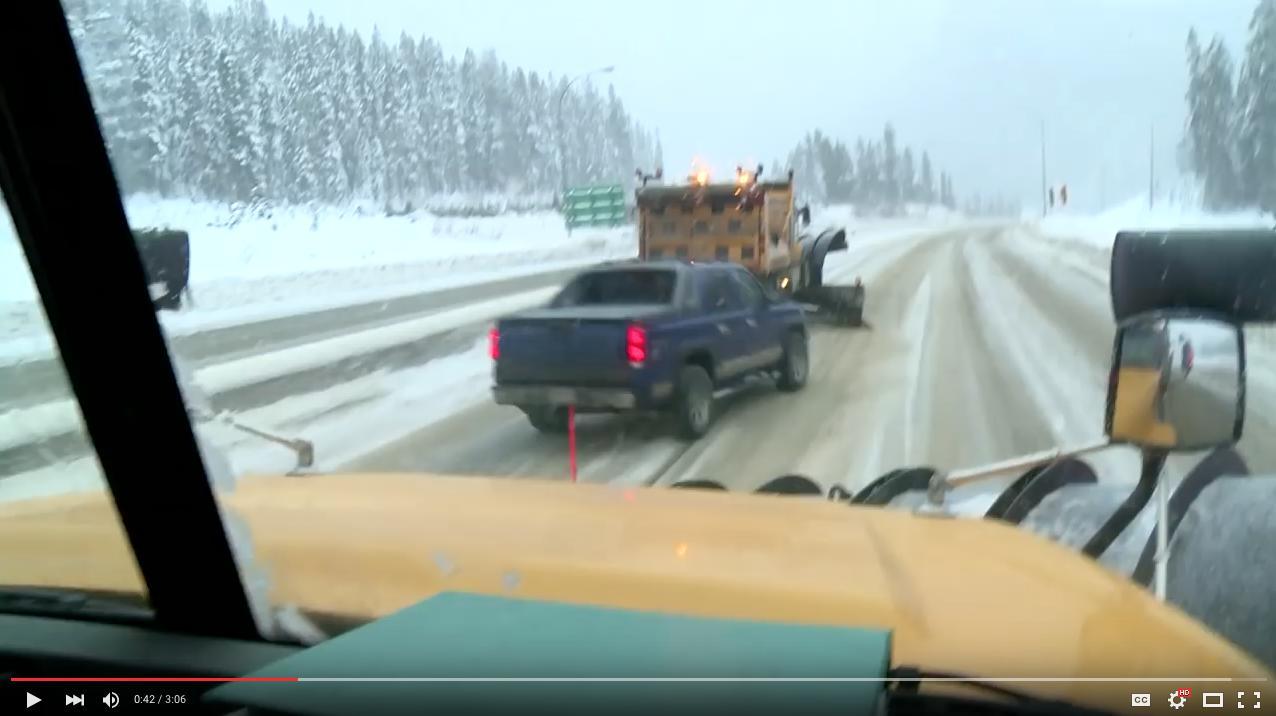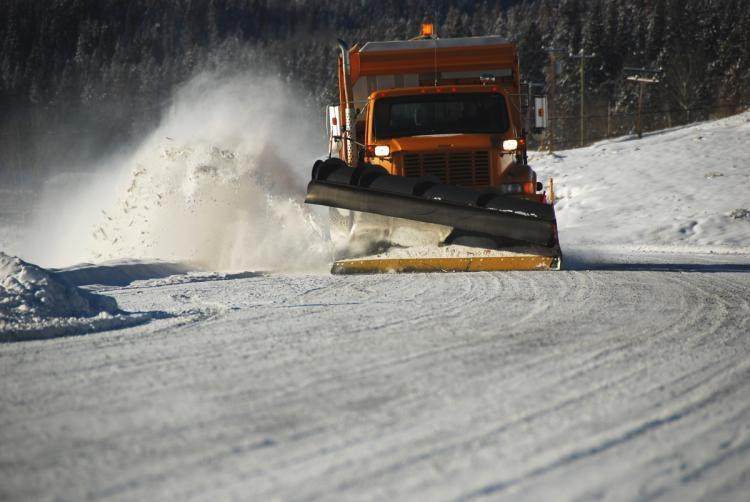The first image is the image on the left, the second image is the image on the right. Analyze the images presented: Is the assertion "Right image includes a camera-facing plow truck driving toward a curve in a snowy road scene." valid? Answer yes or no. Yes. 